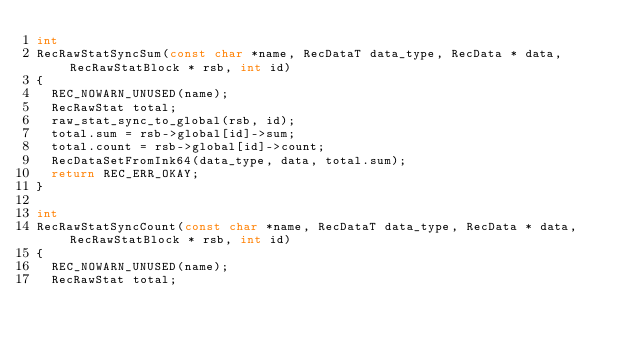<code> <loc_0><loc_0><loc_500><loc_500><_C++_>int
RecRawStatSyncSum(const char *name, RecDataT data_type, RecData * data, RecRawStatBlock * rsb, int id)
{
  REC_NOWARN_UNUSED(name);
  RecRawStat total;
  raw_stat_sync_to_global(rsb, id);
  total.sum = rsb->global[id]->sum;
  total.count = rsb->global[id]->count;
  RecDataSetFromInk64(data_type, data, total.sum);
  return REC_ERR_OKAY;
}

int
RecRawStatSyncCount(const char *name, RecDataT data_type, RecData * data, RecRawStatBlock * rsb, int id)
{
  REC_NOWARN_UNUSED(name);
  RecRawStat total;</code> 